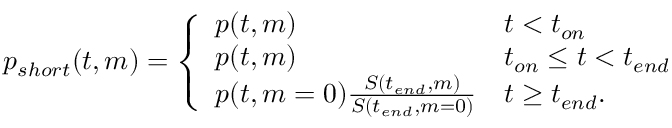Convert formula to latex. <formula><loc_0><loc_0><loc_500><loc_500>\begin{array} { r } { p _ { s h o r t } ( t , m ) = \left \{ \begin{array} { l l } { p ( t , m ) } & { t < t _ { o n } } \\ { p ( t , m ) } & { t _ { o n } \leq t < t _ { e n d } } \\ { p ( t , m = 0 ) \frac { S ( t _ { e n d } , m ) } { S ( t _ { e n d } , m = 0 ) } } & { t \geq t _ { e n d } . } \end{array} } \end{array}</formula> 